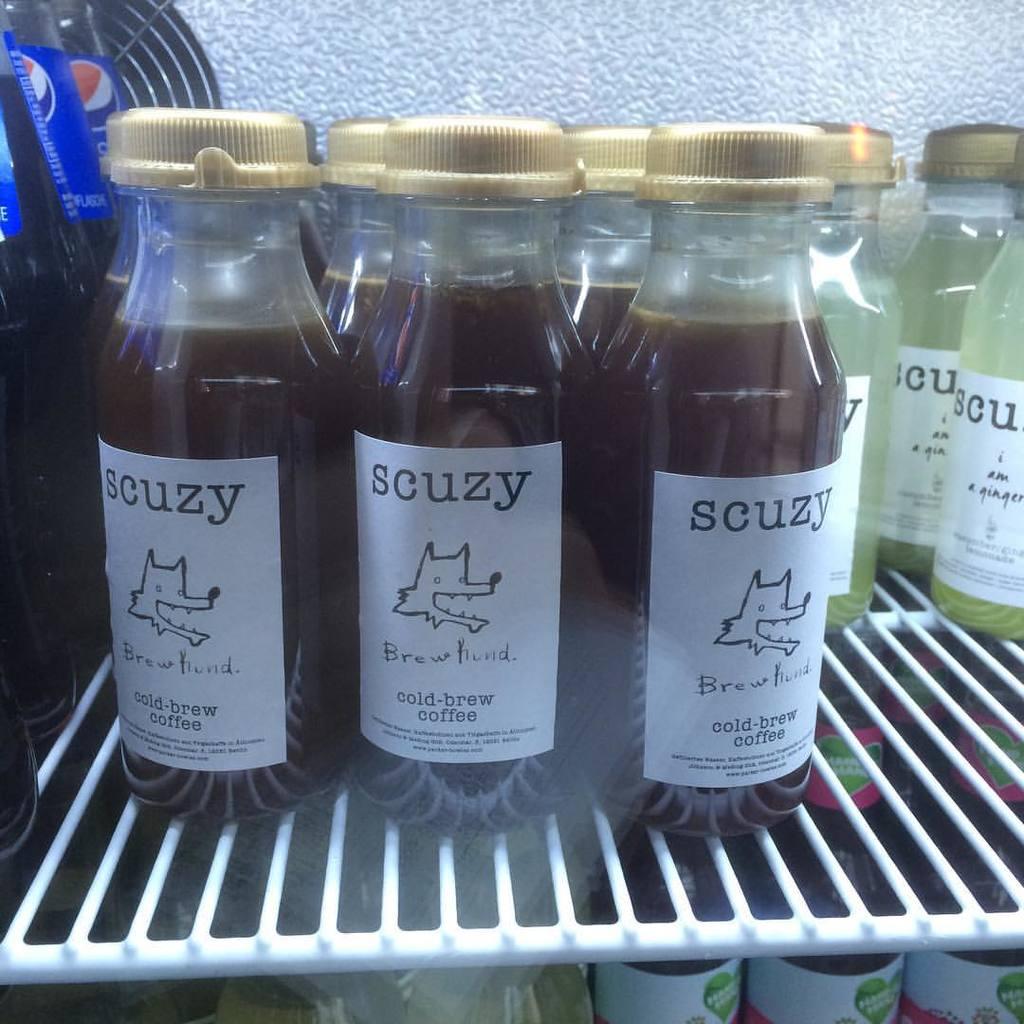What is the name of the coffee?
Offer a very short reply. Scuzy. 